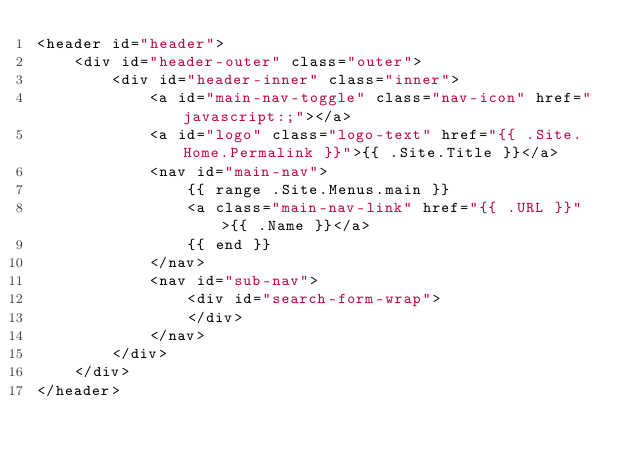Convert code to text. <code><loc_0><loc_0><loc_500><loc_500><_HTML_><header id="header">
    <div id="header-outer" class="outer">
        <div id="header-inner" class="inner">
            <a id="main-nav-toggle" class="nav-icon" href="javascript:;"></a>
            <a id="logo" class="logo-text" href="{{ .Site.Home.Permalink }}">{{ .Site.Title }}</a>
            <nav id="main-nav">
                {{ range .Site.Menus.main }}
                <a class="main-nav-link" href="{{ .URL }}">{{ .Name }}</a>
                {{ end }}
            </nav>
            <nav id="sub-nav">
                <div id="search-form-wrap">
                </div>
            </nav>
        </div>
    </div>
</header>
</code> 